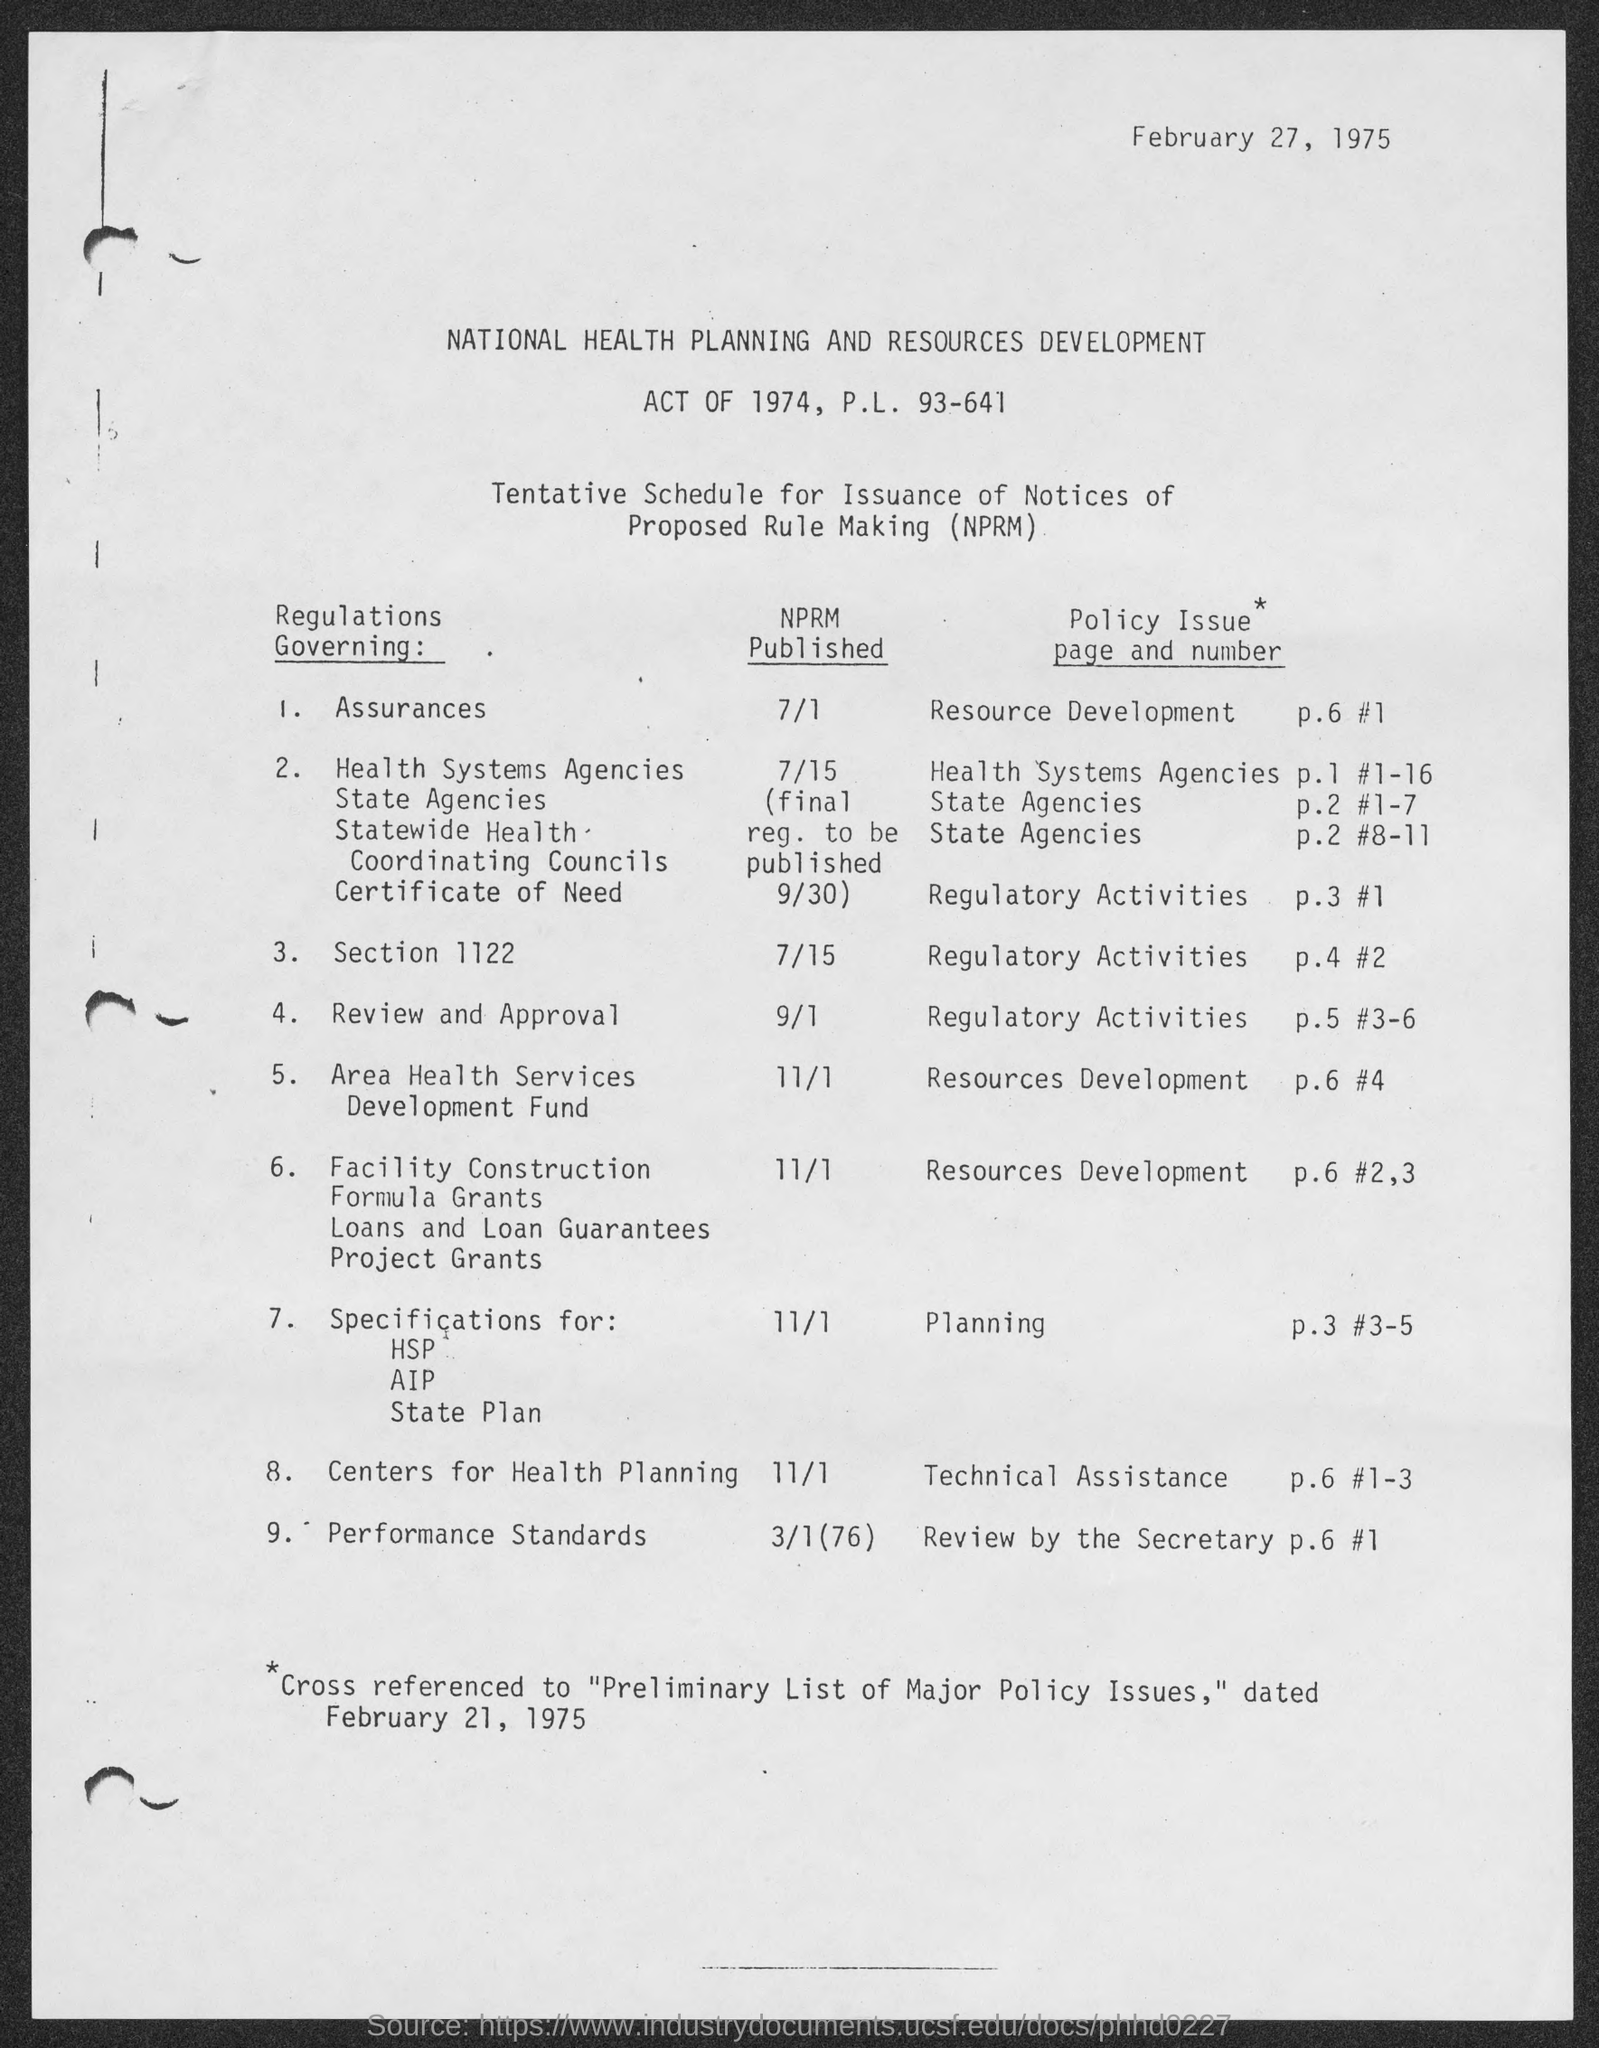What is the fullform of NPRM?
Your answer should be very brief. Notices of Proposed Rule Making. What is the Policy Issue Page and Number for Planning?
Provide a succinct answer. P.3 #3-5. What is the Policy Issue Page and Number for Technical Assistance?
Make the answer very short. P.6 #1-3. When is the NPRM published for Regulations governing assurances?
Keep it short and to the point. 7/1. When is the NPRM published for Regulations governing Section 1122?
Offer a very short reply. 7/15. What is the Policy Issue Page and Number for review by the secretary?
Your answer should be compact. P.6 #1. When is the NPRM published for Regulations governing performance standards?
Your response must be concise. 3/1(76). 